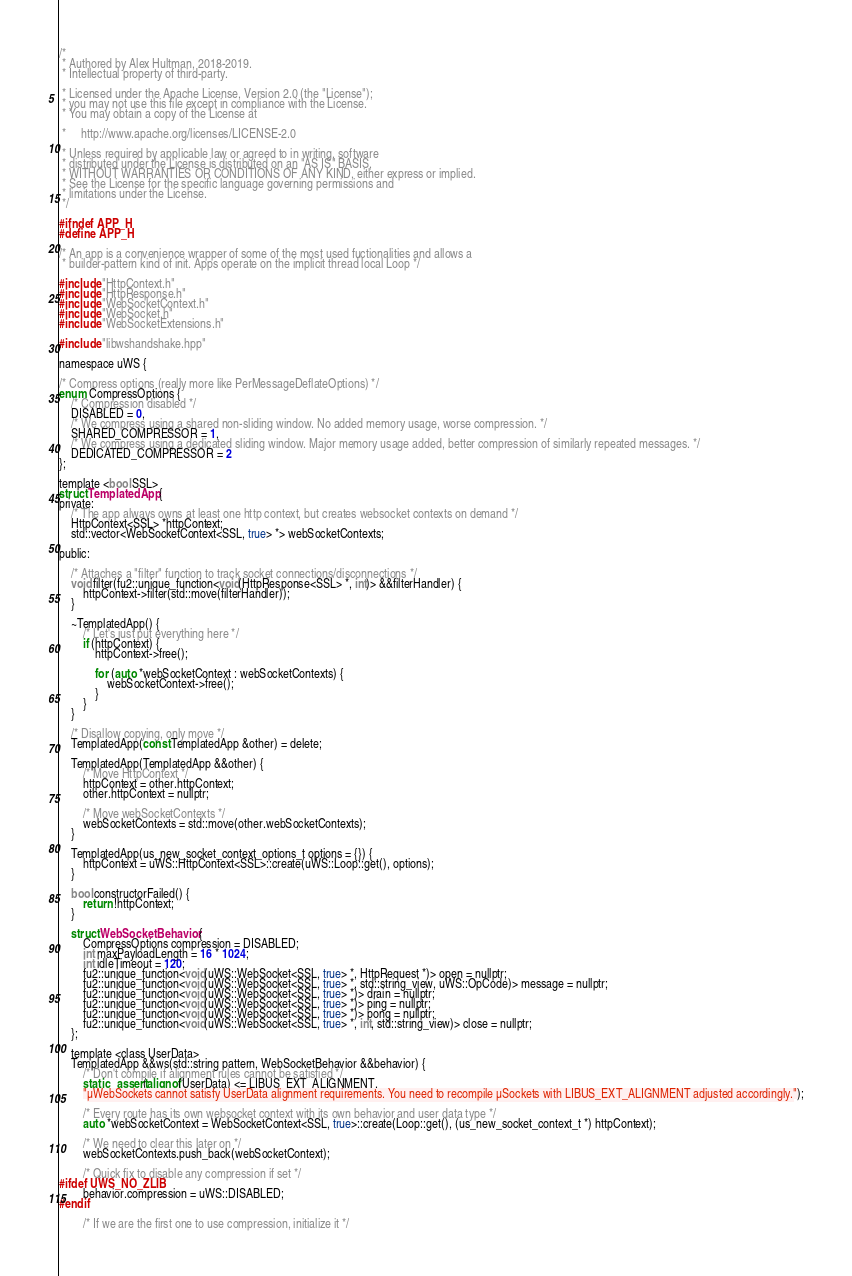<code> <loc_0><loc_0><loc_500><loc_500><_C_>/*
 * Authored by Alex Hultman, 2018-2019.
 * Intellectual property of third-party.

 * Licensed under the Apache License, Version 2.0 (the "License");
 * you may not use this file except in compliance with the License.
 * You may obtain a copy of the License at

 *     http://www.apache.org/licenses/LICENSE-2.0

 * Unless required by applicable law or agreed to in writing, software
 * distributed under the License is distributed on an "AS IS" BASIS,
 * WITHOUT WARRANTIES OR CONDITIONS OF ANY KIND, either express or implied.
 * See the License for the specific language governing permissions and
 * limitations under the License.
 */

#ifndef APP_H
#define APP_H

/* An app is a convenience wrapper of some of the most used fuctionalities and allows a
 * builder-pattern kind of init. Apps operate on the implicit thread local Loop */

#include "HttpContext.h"
#include "HttpResponse.h"
#include "WebSocketContext.h"
#include "WebSocket.h"
#include "WebSocketExtensions.h"

#include "libwshandshake.hpp"

namespace uWS {

/* Compress options (really more like PerMessageDeflateOptions) */
enum CompressOptions {
    /* Compression disabled */
    DISABLED = 0,
    /* We compress using a shared non-sliding window. No added memory usage, worse compression. */
    SHARED_COMPRESSOR = 1,
    /* We compress using a dedicated sliding window. Major memory usage added, better compression of similarly repeated messages. */
    DEDICATED_COMPRESSOR = 2
};

template <bool SSL>
struct TemplatedApp {
private:
    /* The app always owns at least one http context, but creates websocket contexts on demand */
    HttpContext<SSL> *httpContext;
    std::vector<WebSocketContext<SSL, true> *> webSocketContexts;

public:

    /* Attaches a "filter" function to track socket connections/disconnections */
    void filter(fu2::unique_function<void(HttpResponse<SSL> *, int)> &&filterHandler) {
        httpContext->filter(std::move(filterHandler));
    }

    ~TemplatedApp() {
        /* Let's just put everything here */
        if (httpContext) {
            httpContext->free();

            for (auto *webSocketContext : webSocketContexts) {
                webSocketContext->free();
            }
        }
    }

    /* Disallow copying, only move */
    TemplatedApp(const TemplatedApp &other) = delete;

    TemplatedApp(TemplatedApp &&other) {
        /* Move HttpContext */
        httpContext = other.httpContext;
        other.httpContext = nullptr;

        /* Move webSocketContexts */
        webSocketContexts = std::move(other.webSocketContexts);
    }

    TemplatedApp(us_new_socket_context_options_t options = {}) {
        httpContext = uWS::HttpContext<SSL>::create(uWS::Loop::get(), options);
    }

    bool constructorFailed() {
        return !httpContext;
    }

    struct WebSocketBehavior {
        CompressOptions compression = DISABLED;
        int maxPayloadLength = 16 * 1024;
        int idleTimeout = 120;
        fu2::unique_function<void(uWS::WebSocket<SSL, true> *, HttpRequest *)> open = nullptr;
        fu2::unique_function<void(uWS::WebSocket<SSL, true> *, std::string_view, uWS::OpCode)> message = nullptr;
        fu2::unique_function<void(uWS::WebSocket<SSL, true> *)> drain = nullptr;
        fu2::unique_function<void(uWS::WebSocket<SSL, true> *)> ping = nullptr;
        fu2::unique_function<void(uWS::WebSocket<SSL, true> *)> pong = nullptr;
        fu2::unique_function<void(uWS::WebSocket<SSL, true> *, int, std::string_view)> close = nullptr;
    };

    template <class UserData>
    TemplatedApp &&ws(std::string pattern, WebSocketBehavior &&behavior) {
        /* Don't compile if alignment rules cannot be satisfied */
        static_assert(alignof(UserData) <= LIBUS_EXT_ALIGNMENT,
        "µWebSockets cannot satisfy UserData alignment requirements. You need to recompile µSockets with LIBUS_EXT_ALIGNMENT adjusted accordingly.");

        /* Every route has its own websocket context with its own behavior and user data type */
        auto *webSocketContext = WebSocketContext<SSL, true>::create(Loop::get(), (us_new_socket_context_t *) httpContext);

        /* We need to clear this later on */
        webSocketContexts.push_back(webSocketContext);

        /* Quick fix to disable any compression if set */
#ifdef UWS_NO_ZLIB
        behavior.compression = uWS::DISABLED;
#endif

        /* If we are the first one to use compression, initialize it */</code> 